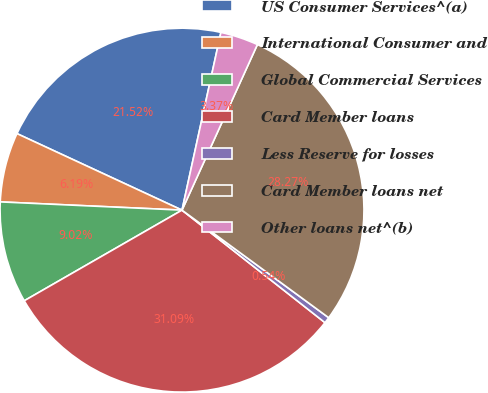<chart> <loc_0><loc_0><loc_500><loc_500><pie_chart><fcel>US Consumer Services^(a)<fcel>International Consumer and<fcel>Global Commercial Services<fcel>Card Member loans<fcel>Less Reserve for losses<fcel>Card Member loans net<fcel>Other loans net^(b)<nl><fcel>21.52%<fcel>6.19%<fcel>9.02%<fcel>31.09%<fcel>0.54%<fcel>28.27%<fcel>3.37%<nl></chart> 